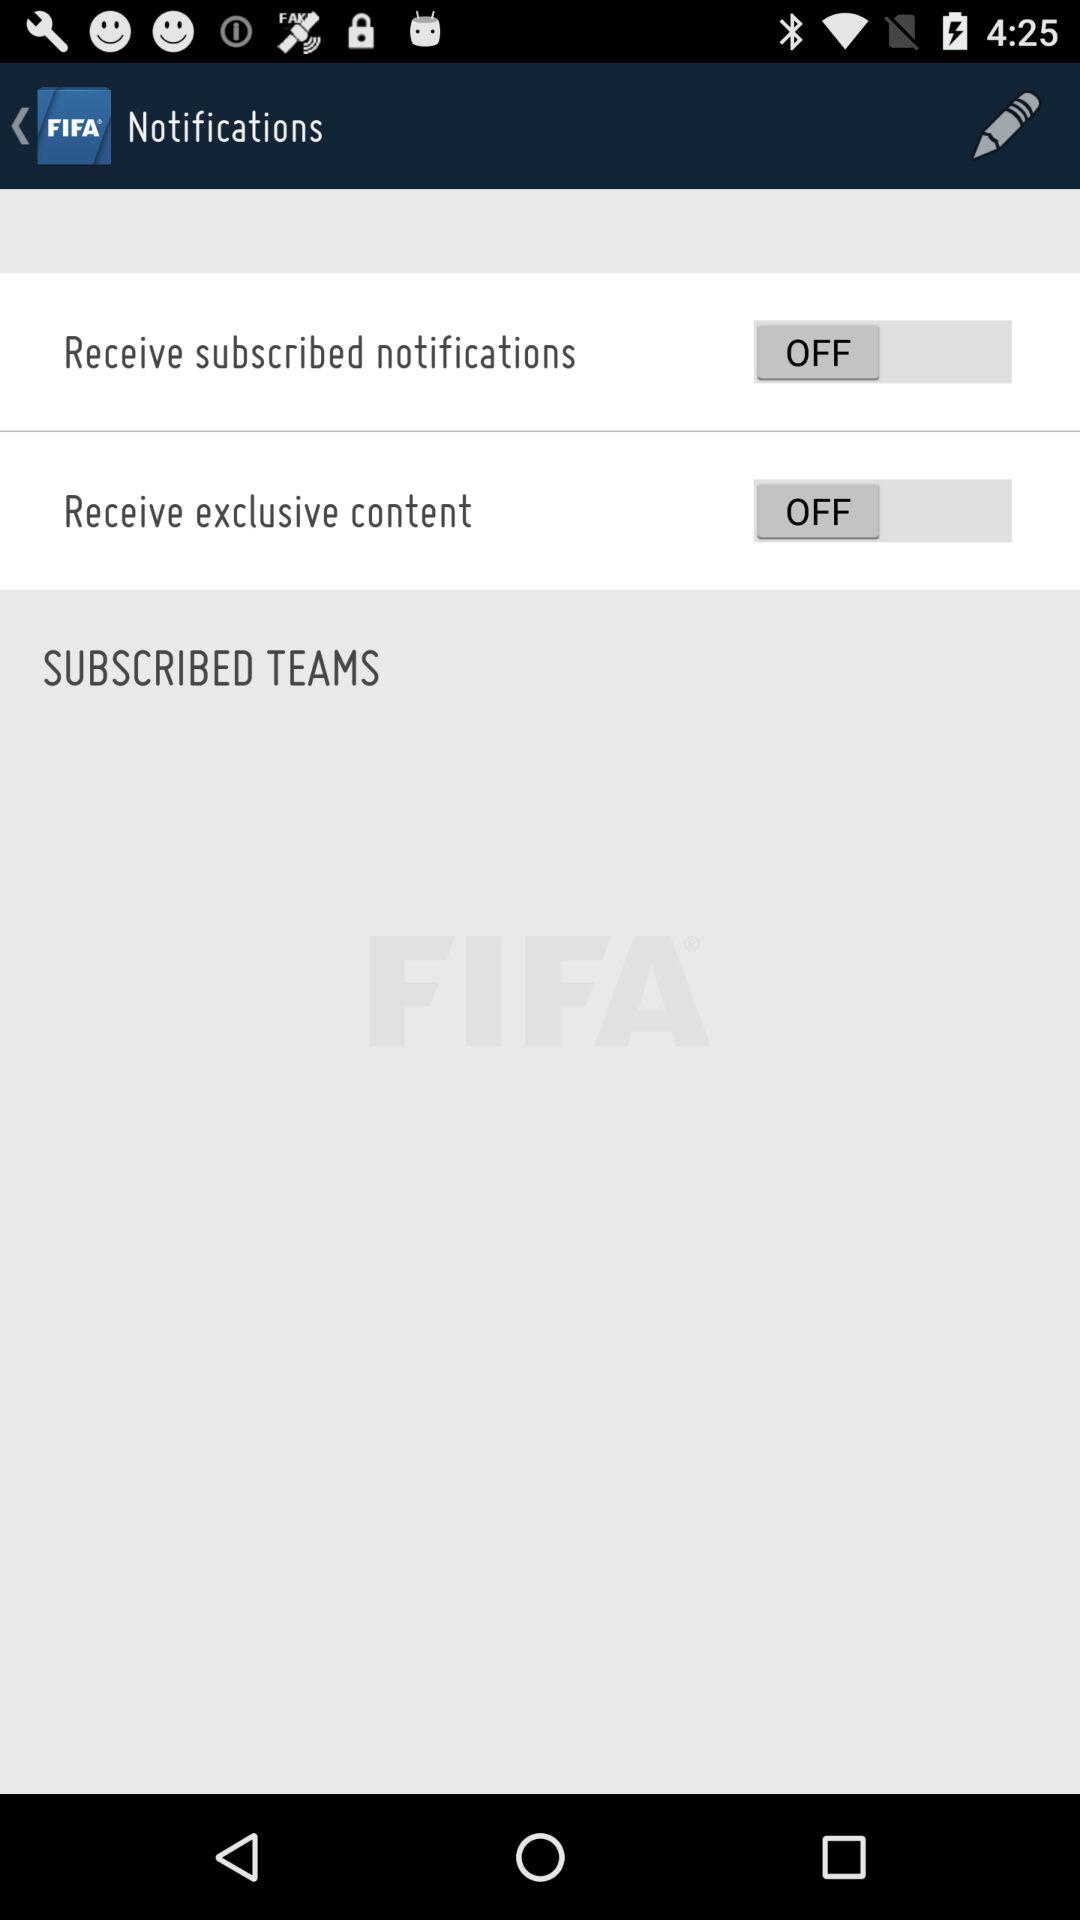What is the status of "Receive subscribed notifications"? The status of "Receive subscribed notifications" is "off". 